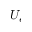Convert formula to latex. <formula><loc_0><loc_0><loc_500><loc_500>U _ { e }</formula> 